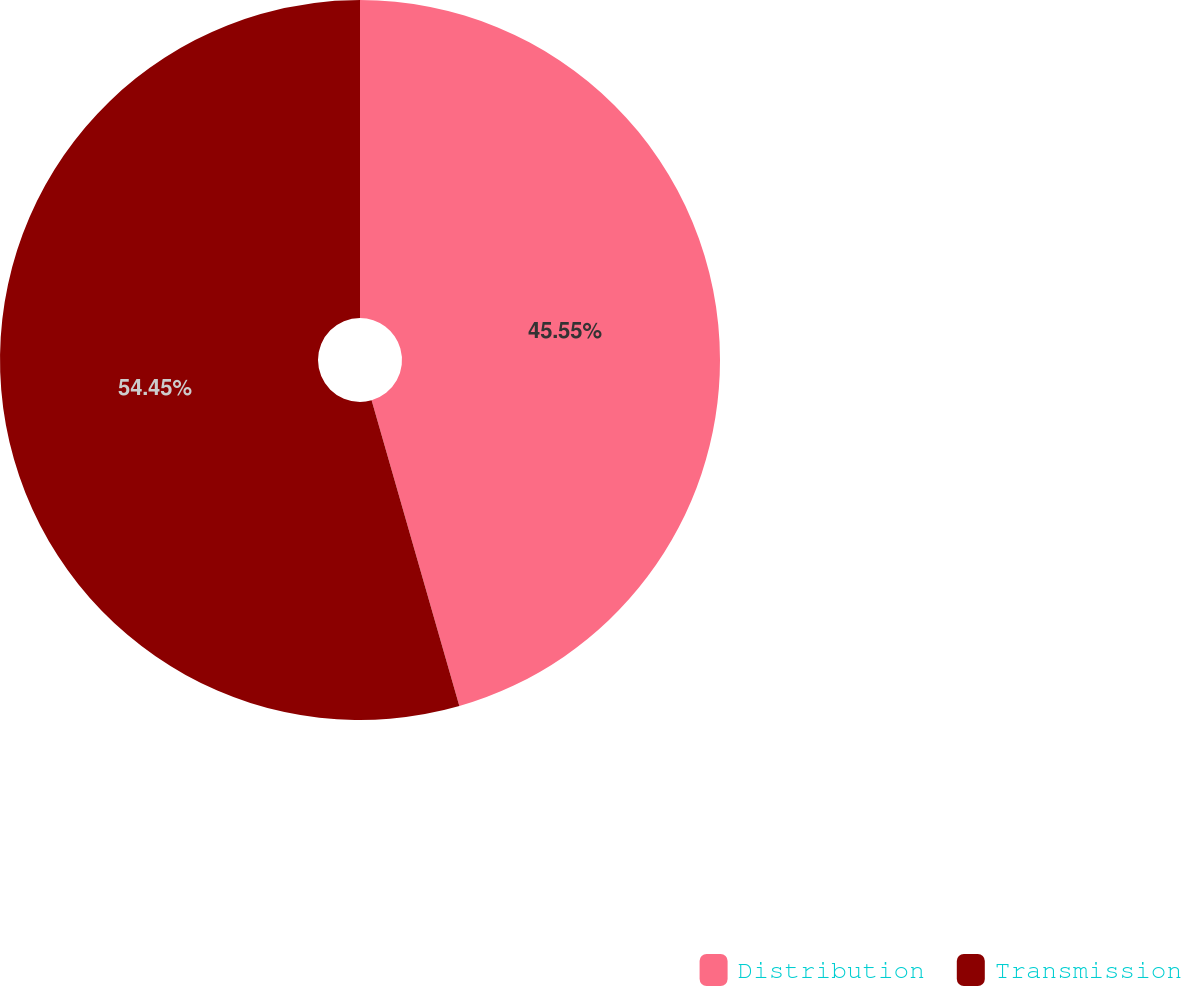Convert chart. <chart><loc_0><loc_0><loc_500><loc_500><pie_chart><fcel>Distribution<fcel>Transmission<nl><fcel>45.55%<fcel>54.45%<nl></chart> 